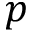<formula> <loc_0><loc_0><loc_500><loc_500>p</formula> 